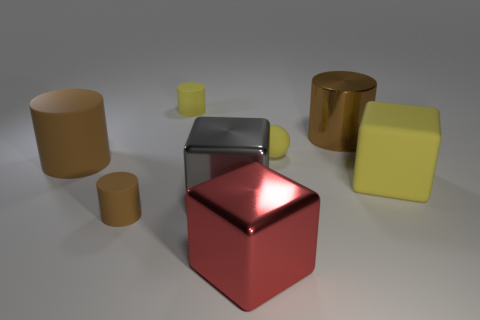Does the cube behind the gray block have the same color as the tiny matte sphere?
Make the answer very short. Yes. Does the small matte ball have the same color as the small cylinder that is right of the tiny brown rubber cylinder?
Make the answer very short. Yes. Is there any other thing that has the same color as the rubber cube?
Provide a succinct answer. Yes. The matte ball that is the same color as the matte cube is what size?
Keep it short and to the point. Small. Are there any cyan spheres that have the same material as the large red block?
Give a very brief answer. No. There is a large thing that is the same color as the big metal cylinder; what shape is it?
Provide a succinct answer. Cylinder. What number of large green blocks are there?
Keep it short and to the point. 0. What number of cubes are either gray rubber things or red things?
Your answer should be compact. 1. There is a rubber cylinder that is the same size as the red cube; what is its color?
Your answer should be very brief. Brown. What number of big objects are both in front of the big yellow cube and to the left of the large red metal block?
Your answer should be very brief. 1. 